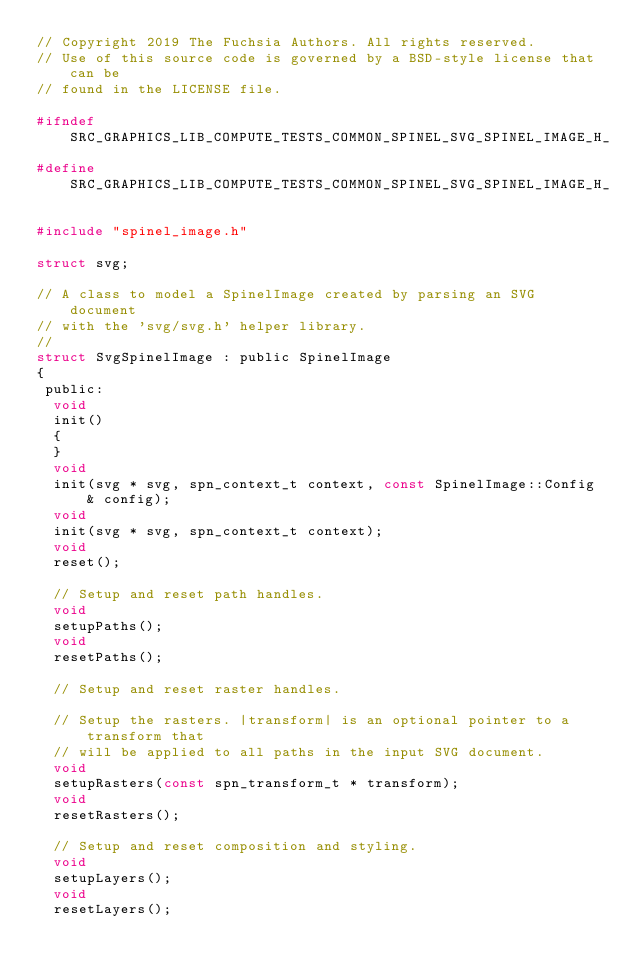Convert code to text. <code><loc_0><loc_0><loc_500><loc_500><_C_>// Copyright 2019 The Fuchsia Authors. All rights reserved.
// Use of this source code is governed by a BSD-style license that can be
// found in the LICENSE file.

#ifndef SRC_GRAPHICS_LIB_COMPUTE_TESTS_COMMON_SPINEL_SVG_SPINEL_IMAGE_H_
#define SRC_GRAPHICS_LIB_COMPUTE_TESTS_COMMON_SPINEL_SVG_SPINEL_IMAGE_H_

#include "spinel_image.h"

struct svg;

// A class to model a SpinelImage created by parsing an SVG document
// with the 'svg/svg.h' helper library.
//
struct SvgSpinelImage : public SpinelImage
{
 public:
  void
  init()
  {
  }
  void
  init(svg * svg, spn_context_t context, const SpinelImage::Config & config);
  void
  init(svg * svg, spn_context_t context);
  void
  reset();

  // Setup and reset path handles.
  void
  setupPaths();
  void
  resetPaths();

  // Setup and reset raster handles.

  // Setup the rasters. |transform| is an optional pointer to a transform that
  // will be applied to all paths in the input SVG document.
  void
  setupRasters(const spn_transform_t * transform);
  void
  resetRasters();

  // Setup and reset composition and styling.
  void
  setupLayers();
  void
  resetLayers();
</code> 